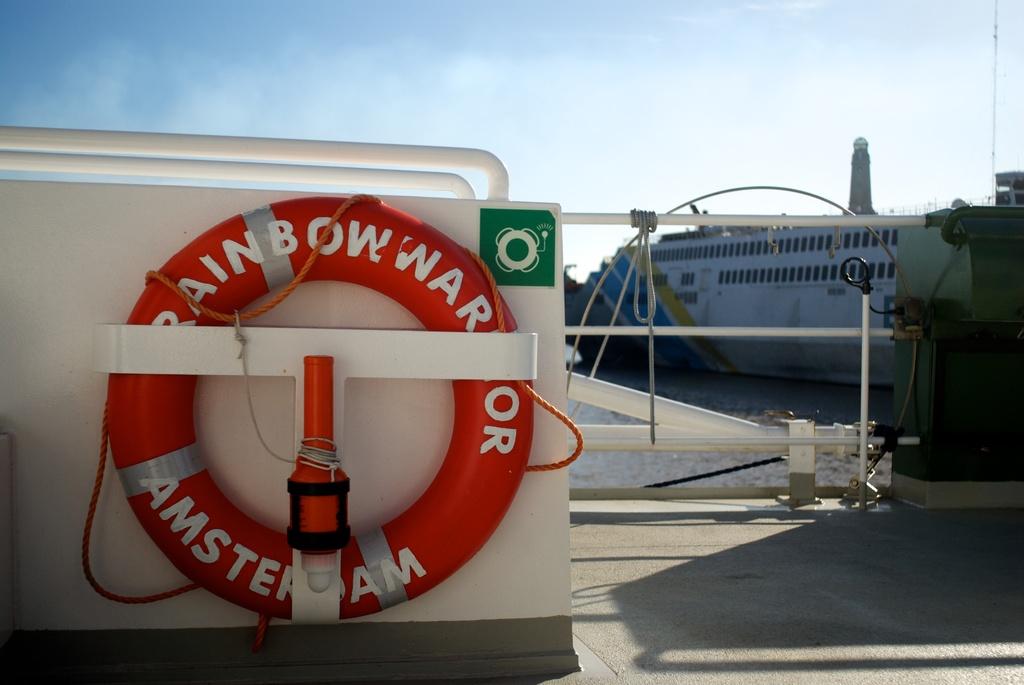What city is shown on the life ring?
Your answer should be very brief. Amsterdam. 